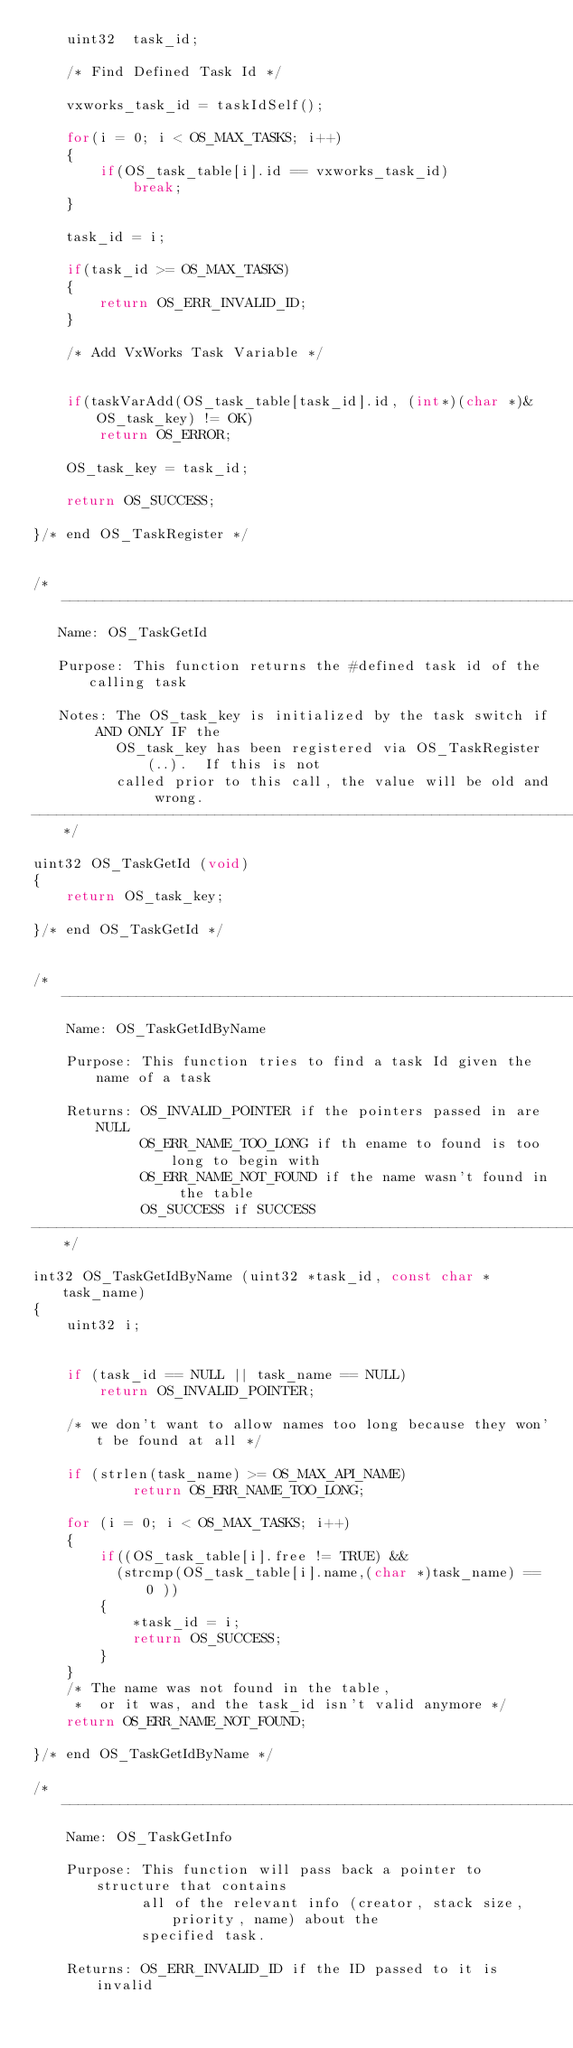Convert code to text. <code><loc_0><loc_0><loc_500><loc_500><_C_>    uint32  task_id;

    /* Find Defined Task Id */

    vxworks_task_id = taskIdSelf();

    for(i = 0; i < OS_MAX_TASKS; i++)
    {
        if(OS_task_table[i].id == vxworks_task_id)
            break;
    }

    task_id = i;

    if(task_id >= OS_MAX_TASKS)
    {
        return OS_ERR_INVALID_ID;
    }

    /* Add VxWorks Task Variable */


    if(taskVarAdd(OS_task_table[task_id].id, (int*)(char *)&OS_task_key) != OK)
        return OS_ERROR;

    OS_task_key = task_id;

    return OS_SUCCESS;

}/* end OS_TaskRegister */


/*---------------------------------------------------------------------------------------
   Name: OS_TaskGetId

   Purpose: This function returns the #defined task id of the calling task

   Notes: The OS_task_key is initialized by the task switch if AND ONLY IF the
          OS_task_key has been registered via OS_TaskRegister(..).  If this is not
          called prior to this call, the value will be old and wrong.
---------------------------------------------------------------------------------------*/

uint32 OS_TaskGetId (void)
{
    return OS_task_key;

}/* end OS_TaskGetId */


/*--------------------------------------------------------------------------------------
    Name: OS_TaskGetIdByName

    Purpose: This function tries to find a task Id given the name of a task

    Returns: OS_INVALID_POINTER if the pointers passed in are NULL
             OS_ERR_NAME_TOO_LONG if th ename to found is too long to begin with
             OS_ERR_NAME_NOT_FOUND if the name wasn't found in the table
             OS_SUCCESS if SUCCESS
---------------------------------------------------------------------------------------*/

int32 OS_TaskGetIdByName (uint32 *task_id, const char *task_name)
{
    uint32 i;


    if (task_id == NULL || task_name == NULL)
        return OS_INVALID_POINTER;

    /* we don't want to allow names too long because they won't be found at all */

    if (strlen(task_name) >= OS_MAX_API_NAME)
            return OS_ERR_NAME_TOO_LONG;

    for (i = 0; i < OS_MAX_TASKS; i++)
    {
        if((OS_task_table[i].free != TRUE) &&
          (strcmp(OS_task_table[i].name,(char *)task_name) == 0 ))
        {
            *task_id = i;
            return OS_SUCCESS;
        }
    }
    /* The name was not found in the table,
     *  or it was, and the task_id isn't valid anymore */
    return OS_ERR_NAME_NOT_FOUND;

}/* end OS_TaskGetIdByName */

/*---------------------------------------------------------------------------------------
    Name: OS_TaskGetInfo

    Purpose: This function will pass back a pointer to structure that contains
             all of the relevant info (creator, stack size, priority, name) about the
             specified task.

    Returns: OS_ERR_INVALID_ID if the ID passed to it is invalid</code> 